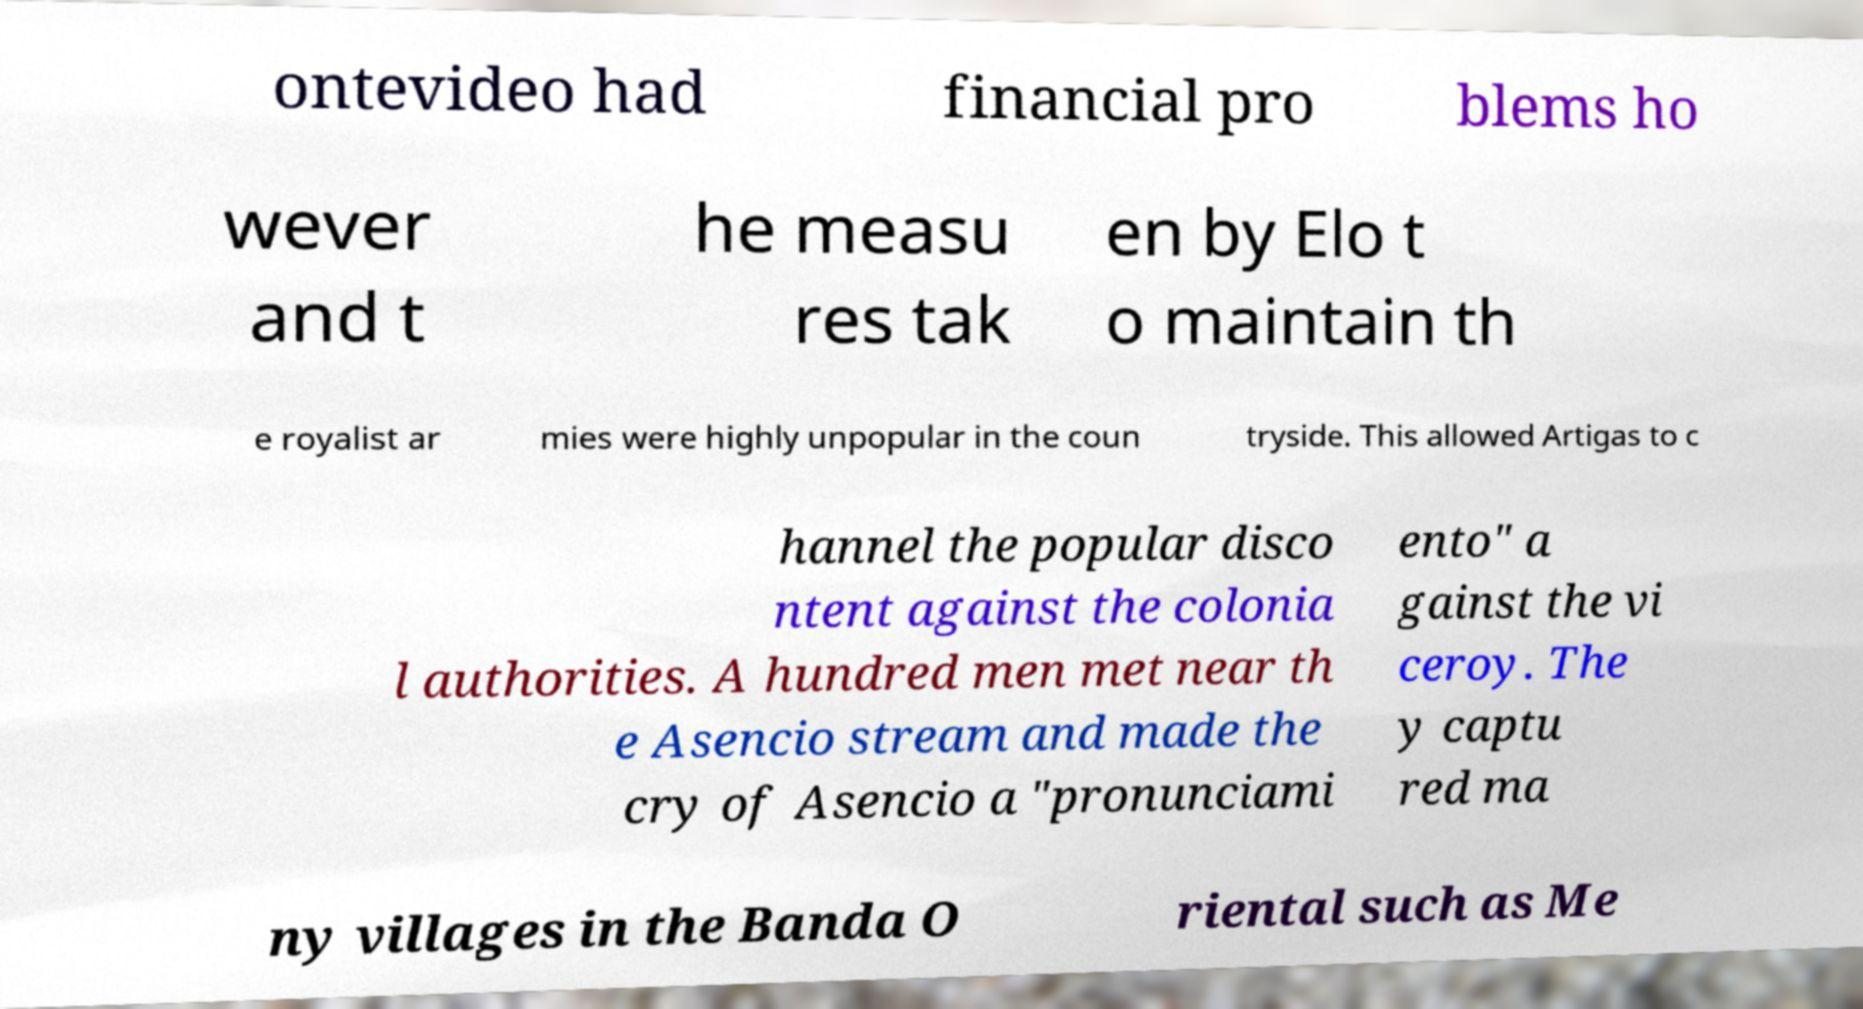What messages or text are displayed in this image? I need them in a readable, typed format. ontevideo had financial pro blems ho wever and t he measu res tak en by Elo t o maintain th e royalist ar mies were highly unpopular in the coun tryside. This allowed Artigas to c hannel the popular disco ntent against the colonia l authorities. A hundred men met near th e Asencio stream and made the cry of Asencio a "pronunciami ento" a gainst the vi ceroy. The y captu red ma ny villages in the Banda O riental such as Me 